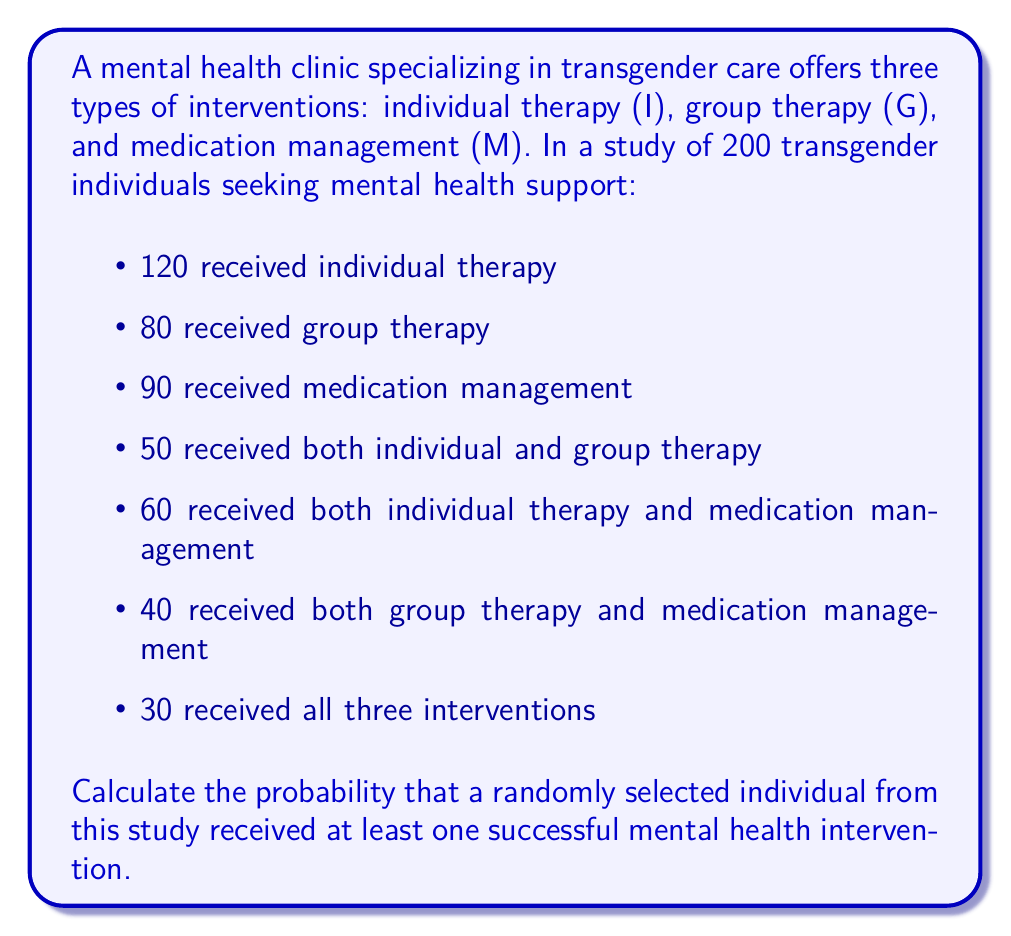Provide a solution to this math problem. To solve this problem, we'll use set theory and the inclusion-exclusion principle.

Let's define our sets:
$I$: individuals who received individual therapy
$G$: individuals who received group therapy
$M$: individuals who received medication management

We're given:
$|I| = 120$, $|G| = 80$, $|M| = 90$
$|I \cap G| = 50$, $|I \cap M| = 60$, $|G \cap M| = 40$
$|I \cap G \cap M| = 30$

To find the number of individuals who received at least one intervention, we need to calculate $|I \cup G \cup M|$.

Using the inclusion-exclusion principle:

$$|I \cup G \cup M| = |I| + |G| + |M| - |I \cap G| - |I \cap M| - |G \cap M| + |I \cap G \cap M|$$

Substituting the given values:

$$|I \cup G \cup M| = 120 + 80 + 90 - 50 - 60 - 40 + 30 = 170$$

Therefore, 170 individuals received at least one intervention.

To calculate the probability, we divide this number by the total number of individuals in the study:

$$P(\text{at least one intervention}) = \frac{170}{200} = 0.85$$
Answer: The probability that a randomly selected individual from this study received at least one successful mental health intervention is $0.85$ or $85\%$. 